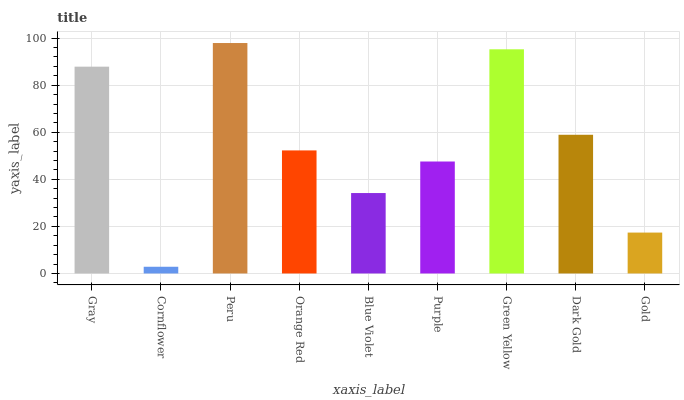Is Cornflower the minimum?
Answer yes or no. Yes. Is Peru the maximum?
Answer yes or no. Yes. Is Peru the minimum?
Answer yes or no. No. Is Cornflower the maximum?
Answer yes or no. No. Is Peru greater than Cornflower?
Answer yes or no. Yes. Is Cornflower less than Peru?
Answer yes or no. Yes. Is Cornflower greater than Peru?
Answer yes or no. No. Is Peru less than Cornflower?
Answer yes or no. No. Is Orange Red the high median?
Answer yes or no. Yes. Is Orange Red the low median?
Answer yes or no. Yes. Is Green Yellow the high median?
Answer yes or no. No. Is Gray the low median?
Answer yes or no. No. 